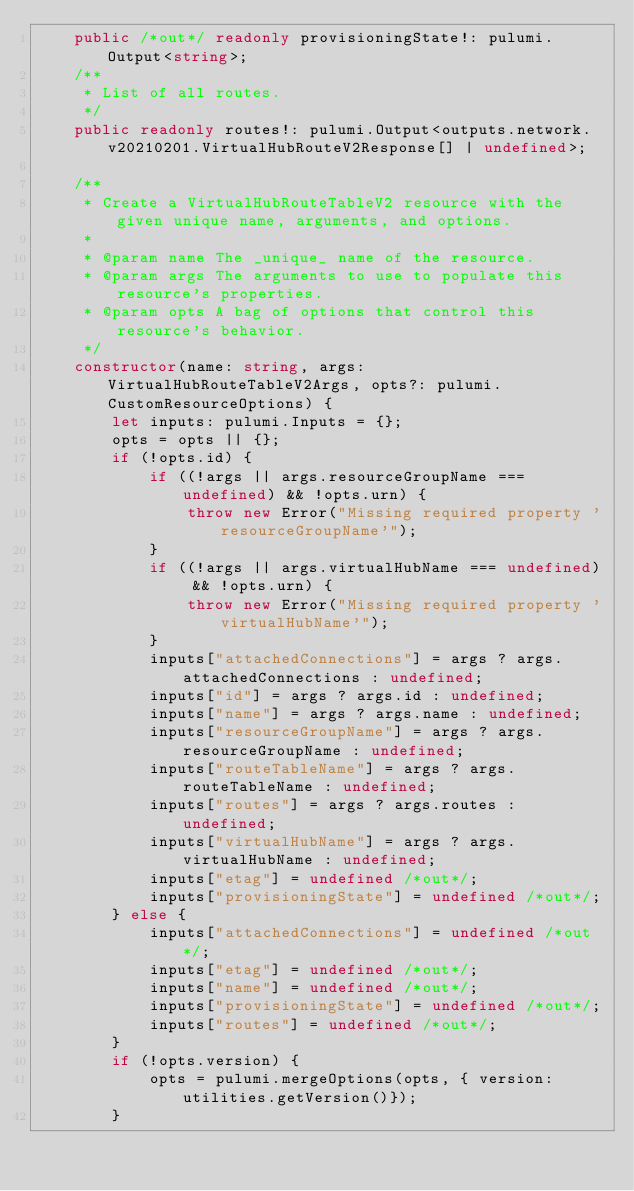<code> <loc_0><loc_0><loc_500><loc_500><_TypeScript_>    public /*out*/ readonly provisioningState!: pulumi.Output<string>;
    /**
     * List of all routes.
     */
    public readonly routes!: pulumi.Output<outputs.network.v20210201.VirtualHubRouteV2Response[] | undefined>;

    /**
     * Create a VirtualHubRouteTableV2 resource with the given unique name, arguments, and options.
     *
     * @param name The _unique_ name of the resource.
     * @param args The arguments to use to populate this resource's properties.
     * @param opts A bag of options that control this resource's behavior.
     */
    constructor(name: string, args: VirtualHubRouteTableV2Args, opts?: pulumi.CustomResourceOptions) {
        let inputs: pulumi.Inputs = {};
        opts = opts || {};
        if (!opts.id) {
            if ((!args || args.resourceGroupName === undefined) && !opts.urn) {
                throw new Error("Missing required property 'resourceGroupName'");
            }
            if ((!args || args.virtualHubName === undefined) && !opts.urn) {
                throw new Error("Missing required property 'virtualHubName'");
            }
            inputs["attachedConnections"] = args ? args.attachedConnections : undefined;
            inputs["id"] = args ? args.id : undefined;
            inputs["name"] = args ? args.name : undefined;
            inputs["resourceGroupName"] = args ? args.resourceGroupName : undefined;
            inputs["routeTableName"] = args ? args.routeTableName : undefined;
            inputs["routes"] = args ? args.routes : undefined;
            inputs["virtualHubName"] = args ? args.virtualHubName : undefined;
            inputs["etag"] = undefined /*out*/;
            inputs["provisioningState"] = undefined /*out*/;
        } else {
            inputs["attachedConnections"] = undefined /*out*/;
            inputs["etag"] = undefined /*out*/;
            inputs["name"] = undefined /*out*/;
            inputs["provisioningState"] = undefined /*out*/;
            inputs["routes"] = undefined /*out*/;
        }
        if (!opts.version) {
            opts = pulumi.mergeOptions(opts, { version: utilities.getVersion()});
        }</code> 